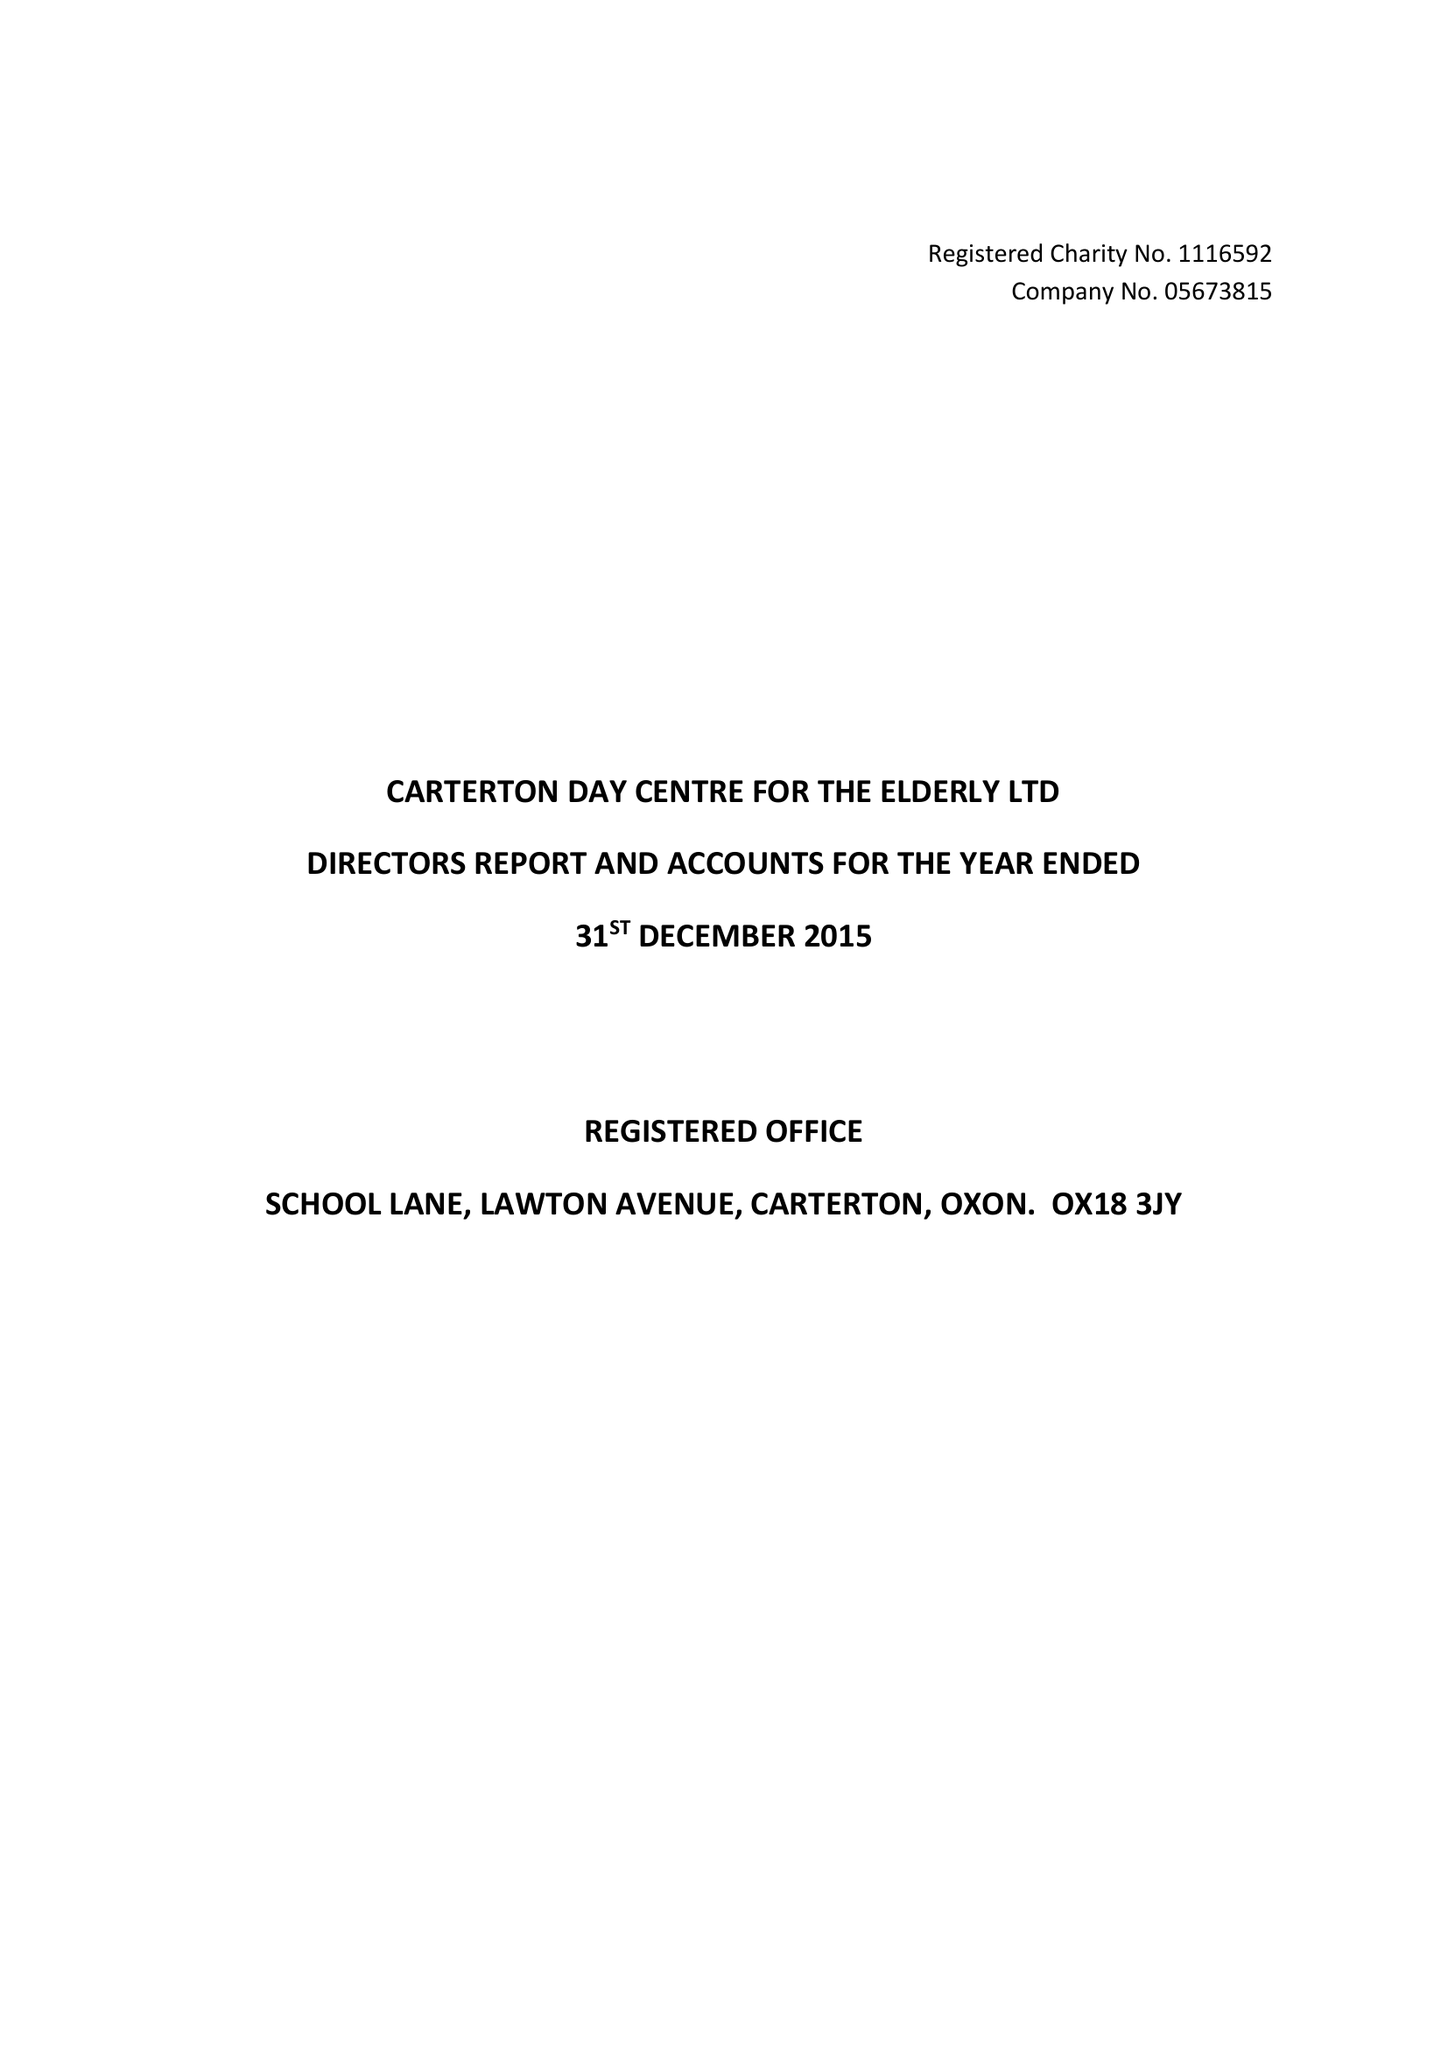What is the value for the report_date?
Answer the question using a single word or phrase. 2015-12-31 